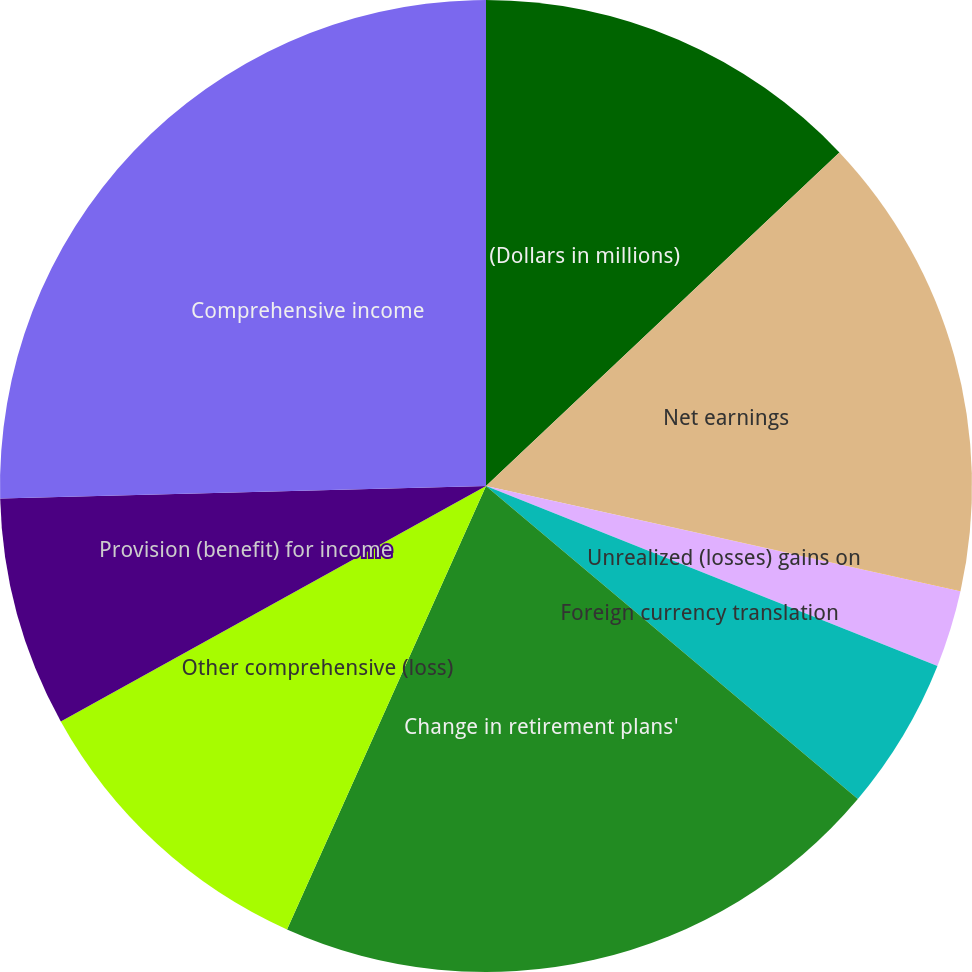<chart> <loc_0><loc_0><loc_500><loc_500><pie_chart><fcel>(Dollars in millions)<fcel>Net earnings<fcel>(Losses) gains on cash flow<fcel>Unrealized (losses) gains on<fcel>Foreign currency translation<fcel>Change in retirement plans'<fcel>Other comprehensive (loss)<fcel>Provision (benefit) for income<fcel>Comprehensive income<nl><fcel>12.96%<fcel>15.5%<fcel>0.02%<fcel>2.56%<fcel>5.1%<fcel>20.58%<fcel>10.24%<fcel>7.64%<fcel>25.41%<nl></chart> 